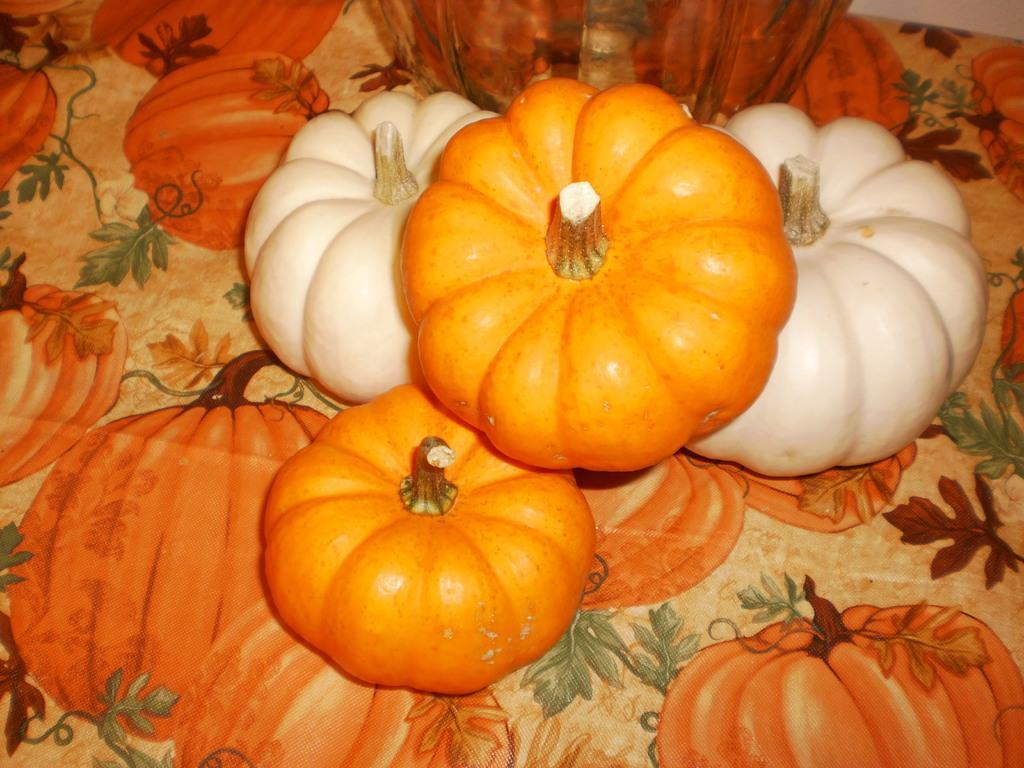Please provide a concise description of this image. In this image there are pumpkins are placed on a table. 